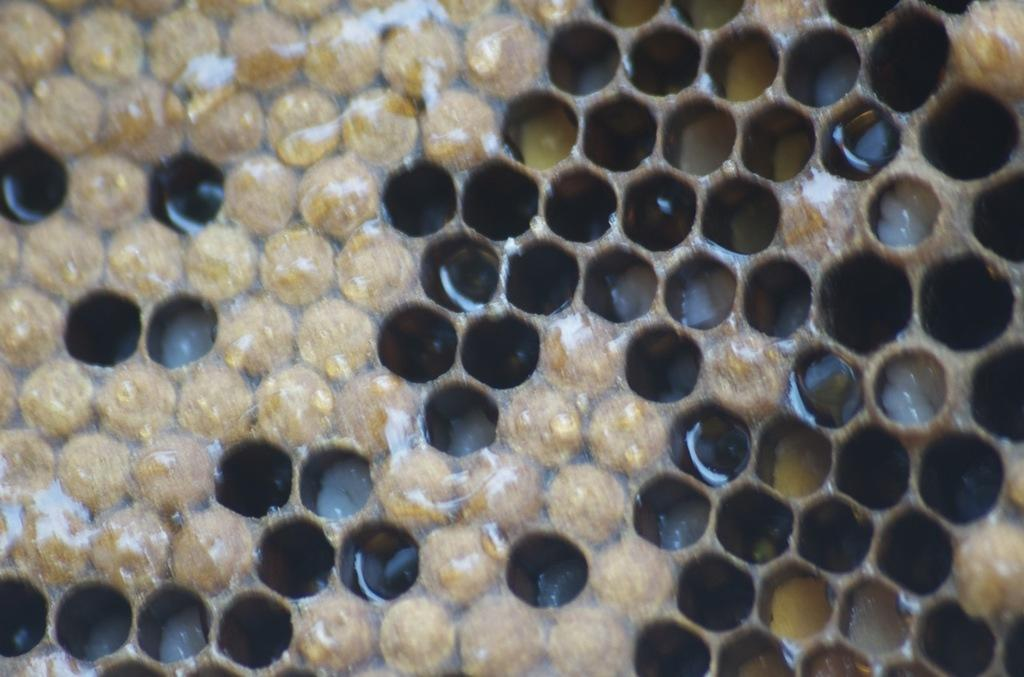What is the main subject of the image? The main subject of the image is a honeycomb. Can you describe the colors of the honeycomb? The honeycomb has brown and cream colors. How many legs can be seen on the honeycomb in the image? There are no legs visible on the honeycomb in the image, as it is an inanimate object made by bees. 